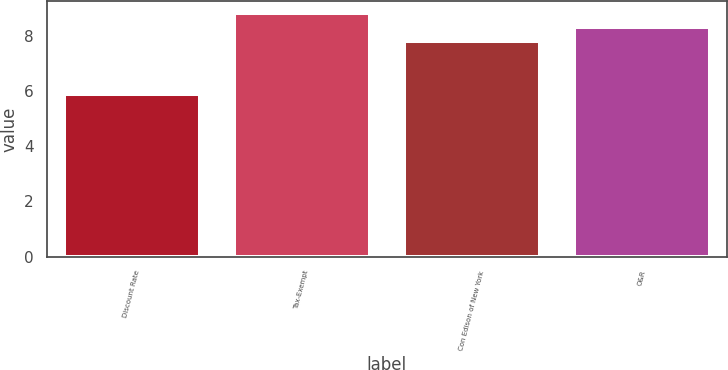Convert chart. <chart><loc_0><loc_0><loc_500><loc_500><bar_chart><fcel>Discount Rate<fcel>Tax-Exempt<fcel>Con Edison of New York<fcel>O&R<nl><fcel>5.9<fcel>8.8<fcel>7.8<fcel>8.3<nl></chart> 